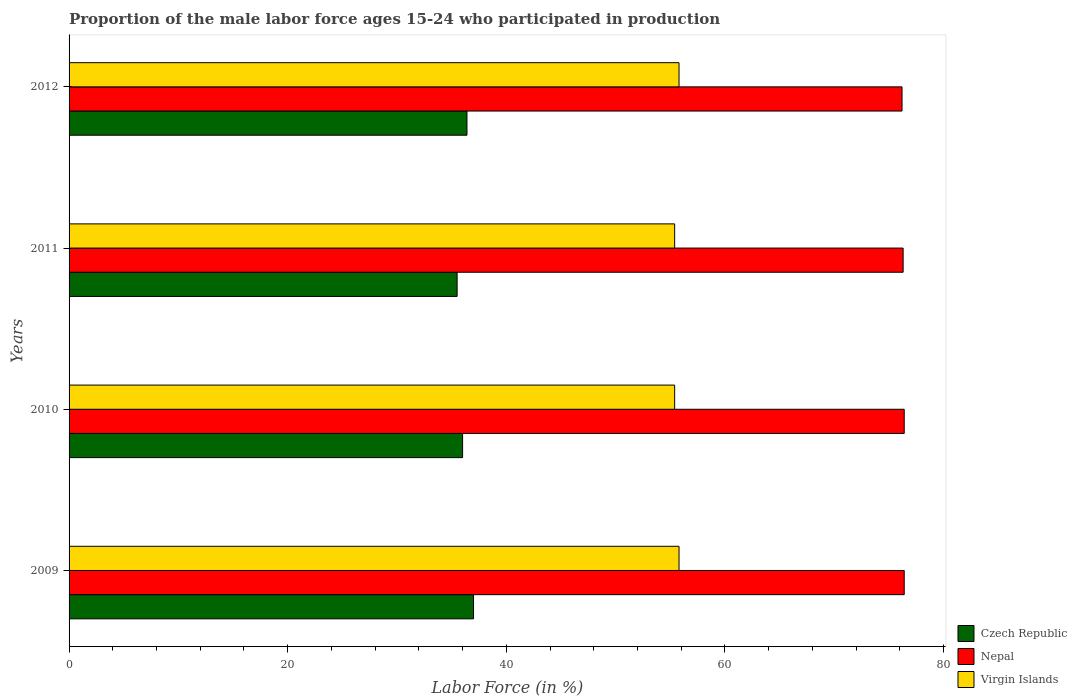How many groups of bars are there?
Your response must be concise. 4. How many bars are there on the 3rd tick from the bottom?
Your response must be concise. 3. What is the proportion of the male labor force who participated in production in Czech Republic in 2009?
Make the answer very short. 37. Across all years, what is the maximum proportion of the male labor force who participated in production in Czech Republic?
Your response must be concise. 37. Across all years, what is the minimum proportion of the male labor force who participated in production in Czech Republic?
Your answer should be very brief. 35.5. In which year was the proportion of the male labor force who participated in production in Nepal maximum?
Keep it short and to the point. 2009. In which year was the proportion of the male labor force who participated in production in Nepal minimum?
Ensure brevity in your answer.  2012. What is the total proportion of the male labor force who participated in production in Czech Republic in the graph?
Offer a terse response. 144.9. What is the difference between the proportion of the male labor force who participated in production in Czech Republic in 2009 and that in 2010?
Keep it short and to the point. 1. What is the difference between the proportion of the male labor force who participated in production in Virgin Islands in 2009 and the proportion of the male labor force who participated in production in Nepal in 2011?
Your answer should be compact. -20.5. What is the average proportion of the male labor force who participated in production in Virgin Islands per year?
Your answer should be very brief. 55.6. In the year 2010, what is the difference between the proportion of the male labor force who participated in production in Nepal and proportion of the male labor force who participated in production in Czech Republic?
Provide a short and direct response. 40.4. In how many years, is the proportion of the male labor force who participated in production in Nepal greater than 76 %?
Your answer should be very brief. 4. What is the ratio of the proportion of the male labor force who participated in production in Virgin Islands in 2009 to that in 2010?
Give a very brief answer. 1.01. Is the proportion of the male labor force who participated in production in Nepal in 2009 less than that in 2010?
Your response must be concise. No. Is the difference between the proportion of the male labor force who participated in production in Nepal in 2009 and 2010 greater than the difference between the proportion of the male labor force who participated in production in Czech Republic in 2009 and 2010?
Offer a terse response. No. What is the difference between the highest and the lowest proportion of the male labor force who participated in production in Nepal?
Keep it short and to the point. 0.2. Is the sum of the proportion of the male labor force who participated in production in Nepal in 2009 and 2010 greater than the maximum proportion of the male labor force who participated in production in Czech Republic across all years?
Make the answer very short. Yes. What does the 2nd bar from the top in 2009 represents?
Make the answer very short. Nepal. What does the 3rd bar from the bottom in 2011 represents?
Offer a terse response. Virgin Islands. Is it the case that in every year, the sum of the proportion of the male labor force who participated in production in Nepal and proportion of the male labor force who participated in production in Czech Republic is greater than the proportion of the male labor force who participated in production in Virgin Islands?
Offer a very short reply. Yes. What is the difference between two consecutive major ticks on the X-axis?
Give a very brief answer. 20. Are the values on the major ticks of X-axis written in scientific E-notation?
Give a very brief answer. No. Does the graph contain any zero values?
Ensure brevity in your answer.  No. Where does the legend appear in the graph?
Make the answer very short. Bottom right. What is the title of the graph?
Your answer should be compact. Proportion of the male labor force ages 15-24 who participated in production. Does "Spain" appear as one of the legend labels in the graph?
Provide a succinct answer. No. What is the label or title of the X-axis?
Your answer should be very brief. Labor Force (in %). What is the Labor Force (in %) of Czech Republic in 2009?
Give a very brief answer. 37. What is the Labor Force (in %) in Nepal in 2009?
Your response must be concise. 76.4. What is the Labor Force (in %) of Virgin Islands in 2009?
Your response must be concise. 55.8. What is the Labor Force (in %) in Nepal in 2010?
Make the answer very short. 76.4. What is the Labor Force (in %) in Virgin Islands in 2010?
Your answer should be very brief. 55.4. What is the Labor Force (in %) of Czech Republic in 2011?
Your answer should be very brief. 35.5. What is the Labor Force (in %) in Nepal in 2011?
Give a very brief answer. 76.3. What is the Labor Force (in %) of Virgin Islands in 2011?
Offer a very short reply. 55.4. What is the Labor Force (in %) in Czech Republic in 2012?
Ensure brevity in your answer.  36.4. What is the Labor Force (in %) of Nepal in 2012?
Provide a succinct answer. 76.2. What is the Labor Force (in %) in Virgin Islands in 2012?
Your response must be concise. 55.8. Across all years, what is the maximum Labor Force (in %) in Czech Republic?
Your answer should be compact. 37. Across all years, what is the maximum Labor Force (in %) in Nepal?
Your response must be concise. 76.4. Across all years, what is the maximum Labor Force (in %) of Virgin Islands?
Offer a terse response. 55.8. Across all years, what is the minimum Labor Force (in %) of Czech Republic?
Make the answer very short. 35.5. Across all years, what is the minimum Labor Force (in %) of Nepal?
Give a very brief answer. 76.2. Across all years, what is the minimum Labor Force (in %) of Virgin Islands?
Offer a very short reply. 55.4. What is the total Labor Force (in %) in Czech Republic in the graph?
Ensure brevity in your answer.  144.9. What is the total Labor Force (in %) of Nepal in the graph?
Provide a short and direct response. 305.3. What is the total Labor Force (in %) in Virgin Islands in the graph?
Provide a short and direct response. 222.4. What is the difference between the Labor Force (in %) of Nepal in 2009 and that in 2010?
Keep it short and to the point. 0. What is the difference between the Labor Force (in %) of Czech Republic in 2009 and that in 2011?
Make the answer very short. 1.5. What is the difference between the Labor Force (in %) of Czech Republic in 2010 and that in 2011?
Offer a terse response. 0.5. What is the difference between the Labor Force (in %) of Virgin Islands in 2010 and that in 2011?
Provide a succinct answer. 0. What is the difference between the Labor Force (in %) of Virgin Islands in 2010 and that in 2012?
Offer a terse response. -0.4. What is the difference between the Labor Force (in %) in Czech Republic in 2011 and that in 2012?
Offer a very short reply. -0.9. What is the difference between the Labor Force (in %) in Nepal in 2011 and that in 2012?
Make the answer very short. 0.1. What is the difference between the Labor Force (in %) in Virgin Islands in 2011 and that in 2012?
Your response must be concise. -0.4. What is the difference between the Labor Force (in %) of Czech Republic in 2009 and the Labor Force (in %) of Nepal in 2010?
Provide a succinct answer. -39.4. What is the difference between the Labor Force (in %) in Czech Republic in 2009 and the Labor Force (in %) in Virgin Islands in 2010?
Offer a terse response. -18.4. What is the difference between the Labor Force (in %) in Czech Republic in 2009 and the Labor Force (in %) in Nepal in 2011?
Offer a terse response. -39.3. What is the difference between the Labor Force (in %) in Czech Republic in 2009 and the Labor Force (in %) in Virgin Islands in 2011?
Give a very brief answer. -18.4. What is the difference between the Labor Force (in %) of Czech Republic in 2009 and the Labor Force (in %) of Nepal in 2012?
Offer a terse response. -39.2. What is the difference between the Labor Force (in %) of Czech Republic in 2009 and the Labor Force (in %) of Virgin Islands in 2012?
Make the answer very short. -18.8. What is the difference between the Labor Force (in %) of Nepal in 2009 and the Labor Force (in %) of Virgin Islands in 2012?
Your answer should be compact. 20.6. What is the difference between the Labor Force (in %) in Czech Republic in 2010 and the Labor Force (in %) in Nepal in 2011?
Offer a terse response. -40.3. What is the difference between the Labor Force (in %) in Czech Republic in 2010 and the Labor Force (in %) in Virgin Islands in 2011?
Make the answer very short. -19.4. What is the difference between the Labor Force (in %) of Czech Republic in 2010 and the Labor Force (in %) of Nepal in 2012?
Your answer should be very brief. -40.2. What is the difference between the Labor Force (in %) in Czech Republic in 2010 and the Labor Force (in %) in Virgin Islands in 2012?
Provide a succinct answer. -19.8. What is the difference between the Labor Force (in %) in Nepal in 2010 and the Labor Force (in %) in Virgin Islands in 2012?
Provide a short and direct response. 20.6. What is the difference between the Labor Force (in %) of Czech Republic in 2011 and the Labor Force (in %) of Nepal in 2012?
Your answer should be compact. -40.7. What is the difference between the Labor Force (in %) of Czech Republic in 2011 and the Labor Force (in %) of Virgin Islands in 2012?
Ensure brevity in your answer.  -20.3. What is the average Labor Force (in %) of Czech Republic per year?
Give a very brief answer. 36.23. What is the average Labor Force (in %) in Nepal per year?
Your response must be concise. 76.33. What is the average Labor Force (in %) of Virgin Islands per year?
Offer a terse response. 55.6. In the year 2009, what is the difference between the Labor Force (in %) of Czech Republic and Labor Force (in %) of Nepal?
Provide a short and direct response. -39.4. In the year 2009, what is the difference between the Labor Force (in %) in Czech Republic and Labor Force (in %) in Virgin Islands?
Give a very brief answer. -18.8. In the year 2009, what is the difference between the Labor Force (in %) of Nepal and Labor Force (in %) of Virgin Islands?
Offer a very short reply. 20.6. In the year 2010, what is the difference between the Labor Force (in %) of Czech Republic and Labor Force (in %) of Nepal?
Your answer should be very brief. -40.4. In the year 2010, what is the difference between the Labor Force (in %) in Czech Republic and Labor Force (in %) in Virgin Islands?
Your response must be concise. -19.4. In the year 2010, what is the difference between the Labor Force (in %) in Nepal and Labor Force (in %) in Virgin Islands?
Give a very brief answer. 21. In the year 2011, what is the difference between the Labor Force (in %) in Czech Republic and Labor Force (in %) in Nepal?
Your response must be concise. -40.8. In the year 2011, what is the difference between the Labor Force (in %) in Czech Republic and Labor Force (in %) in Virgin Islands?
Keep it short and to the point. -19.9. In the year 2011, what is the difference between the Labor Force (in %) in Nepal and Labor Force (in %) in Virgin Islands?
Your response must be concise. 20.9. In the year 2012, what is the difference between the Labor Force (in %) of Czech Republic and Labor Force (in %) of Nepal?
Offer a very short reply. -39.8. In the year 2012, what is the difference between the Labor Force (in %) in Czech Republic and Labor Force (in %) in Virgin Islands?
Your answer should be very brief. -19.4. In the year 2012, what is the difference between the Labor Force (in %) in Nepal and Labor Force (in %) in Virgin Islands?
Provide a short and direct response. 20.4. What is the ratio of the Labor Force (in %) in Czech Republic in 2009 to that in 2010?
Give a very brief answer. 1.03. What is the ratio of the Labor Force (in %) of Virgin Islands in 2009 to that in 2010?
Make the answer very short. 1.01. What is the ratio of the Labor Force (in %) of Czech Republic in 2009 to that in 2011?
Offer a very short reply. 1.04. What is the ratio of the Labor Force (in %) of Czech Republic in 2009 to that in 2012?
Make the answer very short. 1.02. What is the ratio of the Labor Force (in %) in Czech Republic in 2010 to that in 2011?
Offer a very short reply. 1.01. What is the ratio of the Labor Force (in %) in Nepal in 2010 to that in 2011?
Offer a terse response. 1. What is the ratio of the Labor Force (in %) of Virgin Islands in 2010 to that in 2011?
Your response must be concise. 1. What is the ratio of the Labor Force (in %) in Czech Republic in 2010 to that in 2012?
Your answer should be very brief. 0.99. What is the ratio of the Labor Force (in %) in Czech Republic in 2011 to that in 2012?
Offer a terse response. 0.98. What is the difference between the highest and the second highest Labor Force (in %) in Nepal?
Your answer should be compact. 0. What is the difference between the highest and the second highest Labor Force (in %) in Virgin Islands?
Keep it short and to the point. 0. What is the difference between the highest and the lowest Labor Force (in %) in Czech Republic?
Give a very brief answer. 1.5. 